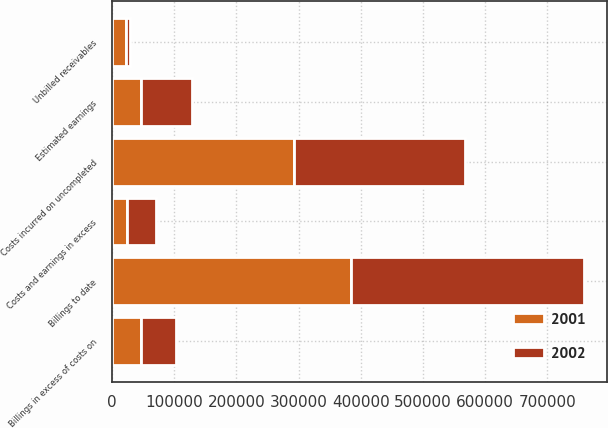Convert chart to OTSL. <chart><loc_0><loc_0><loc_500><loc_500><stacked_bar_chart><ecel><fcel>Costs incurred on uncompleted<fcel>Estimated earnings<fcel>Unbilled receivables<fcel>Billings to date<fcel>Costs and earnings in excess<fcel>Billings in excess of costs on<nl><fcel>2001<fcel>291898<fcel>47279<fcel>21823<fcel>384035<fcel>24088<fcel>47123<nl><fcel>2002<fcel>275663<fcel>82112<fcel>7311<fcel>374731<fcel>46453<fcel>56098<nl></chart> 